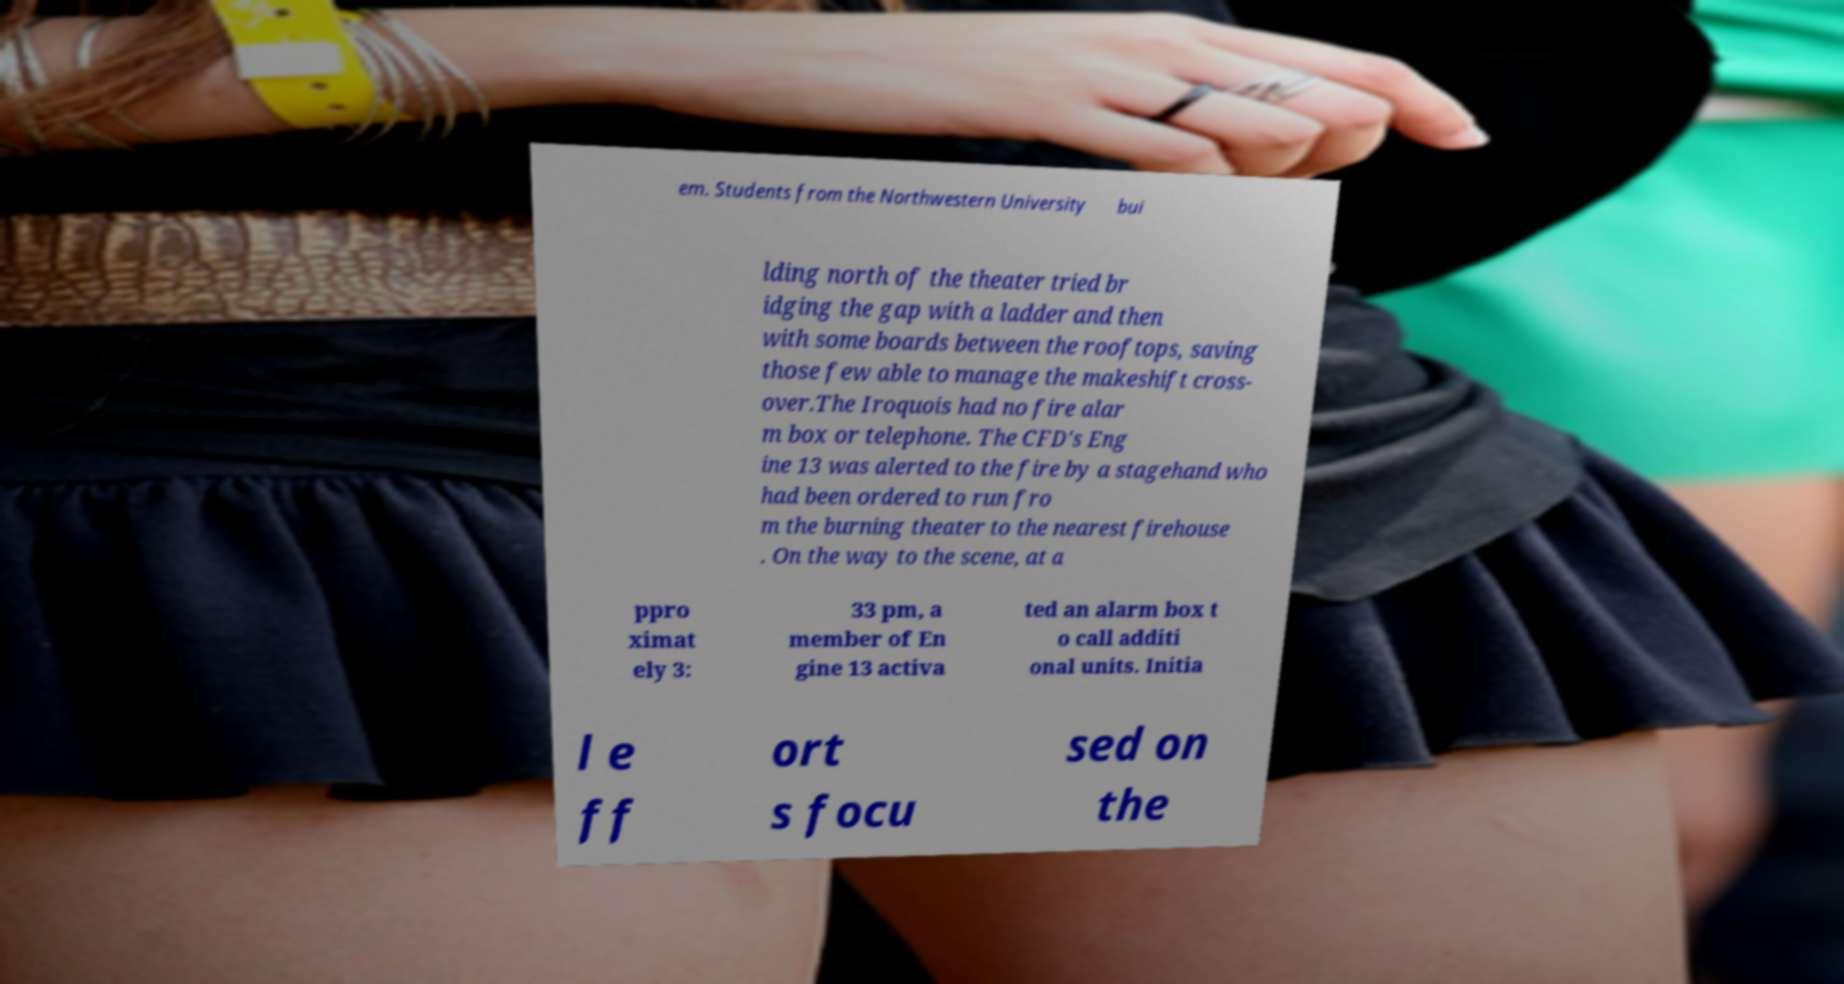There's text embedded in this image that I need extracted. Can you transcribe it verbatim? em. Students from the Northwestern University bui lding north of the theater tried br idging the gap with a ladder and then with some boards between the rooftops, saving those few able to manage the makeshift cross- over.The Iroquois had no fire alar m box or telephone. The CFD's Eng ine 13 was alerted to the fire by a stagehand who had been ordered to run fro m the burning theater to the nearest firehouse . On the way to the scene, at a ppro ximat ely 3: 33 pm, a member of En gine 13 activa ted an alarm box t o call additi onal units. Initia l e ff ort s focu sed on the 